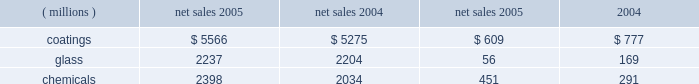Management 2019s discussion and analysis action antitrust legal settlement .
Net income for 2005 and 2004 included an aftertax charge of $ 13 million , or 8 cents a share , and $ 19 million , or 11 cents a share , respectively , to reflect the net increase in the current value of the company 2019s obligation under the ppg settlement arrangement relating to asbestos claims .
Results of business segments net sales operating income ( millions ) 2005 2004 2005 2004 .
Coatings sales increased $ 291 million or 5% ( 5 % ) in 2005 .
Sales increased 3% ( 3 % ) due to higher selling prices across all businesses except automotive ; 1% ( 1 % ) due to improved volumes as increases in our aerospace , architectural and original equipment automotive businesses offset volume declines in automotive refinish and industrial coatings ; and 1% ( 1 % ) due to the positive effects of foreign currency translation .
Operating income decreased $ 168 million in 2005 .
The adverse impact of inflation totaled $ 315 million , of which $ 245 million was attributable to higher raw material costs .
Higher year-over-year selling prices increased operating earnings by $ 169 million .
Coatings operating earnings were reduced by the $ 132 million charge for the cost of the marvin legal settlement net of insurance recoveries .
Other factors increasing coatings operating income in 2005 were the increased sales volumes described above , manufacturing efficiencies , formula cost reductions and higher other income .
Glass sales increased $ 33 million or 1% ( 1 % ) in 2005 .
Sales increased 1% ( 1 % ) due to improved volumes as increases in our automotive replacement glass , insurance and services and performance glazings ( flat glass ) businesses offset volume declines in our fiber glass and automotive original equipment glass businesses .
The positive effects of foreign currency translation were largely offset by lower selling prices primarily in our automotive replacement glass and automotive original equipment businesses .
Operating income decreased $ 113 million in 2005 .
The federal glass class action antitrust legal settlement of $ 61 million , the $ 49 million impact of rising natural gas costs and the absence of the $ 19 million gain in 2004 from the sale/ leaseback of precious metal combined to account for a reduction in operating earnings of $ 129 million .
The remaining year-over-year increase in glass operating earnings of $ 16 million resulted primarily from improved manufacturing efficiencies and lower overhead costs exceeding the adverse impact of other inflation .
Our continuing efforts in 2005 to position the fiber glass business for future growth in profitability were adversely impacted by the rise in fourth quarter natural gas prices , slightly lower year-over-year sales , lower equity earnings due to weaker pricing in the asian electronics market , and the absence of the $ 19 million gain which occurred in 2004 stemming from the sale/ leaseback of precious metals .
Despite high energy costs , we expect fiber glass earnings to improve in 2006 because of price strengthening in the asian electronics market , which began to occur in the fourth quarter of 2005 , increased cost reduction initiatives and the positive impact resulting from the start up of our new joint venture in china .
This joint venture will produce high labor content fiber glass reinforcement products and take advantage of lower labor costs , allowing us to refocus our u.s .
Production capacity on higher margin direct process products .
The 2005 operating earnings of our north american automotive oem glass business declined by $ 30 million compared with 2004 .
Significant structural changes continue to occur in the north american automotive industry , including the loss of u.s .
Market share by general motors and ford .
This has created a very challenging and competitive environment for all suppliers to the domestic oems , including our business .
About half of the decline in earnings resulted from the impact of rising natural gas costs , particularly in the fourth quarter , combined with the traditional adverse impact of year-over-year sales price reductions producing a decline in earnings that exceeded our successful efforts to reduce manufacturing costs .
The other half of the 2005 decline was due to lower sales volumes and mix and higher new program launch costs .
The challenging competitive environment and high energy prices will continue in 2006 .
Our business is working in 2006 to improve its performance through increased manufacturing efficiencies , structural cost reduction initiatives , focusing on profitable growth opportunities and improving our sales mix .
Chemicals sales increased $ 364 million or 18% ( 18 % ) in 2005 .
Sales increased 21% ( 21 % ) due to higher selling prices , primarily for chlor-alkali products , and 1% ( 1 % ) due to the combination of an acquisition in our optical products business and the positive effects of foreign currency translation .
Total volumes declined 4% ( 4 % ) as volume increases in optical products were more than offset by volume declines in chlor-alkali and fine chemicals .
Volume in chlor-alkali products and silicas were adversely impacted in the third and fourth quarters by the hurricanes .
Operating income increased $ 160 million in 2005 .
The primary factor increasing operating income was the record high selling prices in chlor-alkali .
Factors decreasing operating income were higher inflation , including $ 136 million due to increased energy and ethylene costs ; $ 34 million of direct costs related to the impact of the hurricanes ; $ 27 million due to the asset impairment charge related to our fine chemicals business ; lower sales volumes ; higher manufacturing costs and increased environmental expenses .
The increase in chemicals operating earnings occurred primarily through the first eight months of 2005 .
The hurricanes hit in september impacting volumes and costs in september through november and contributing to the rise in natural gas prices which lowered fourth quarter chemicals earnings by $ 58 million , almost 57% ( 57 % ) of the full year impact of higher natural gas prices .
The damage caused by hurricane rita resulted in the shutdown of our lake charles , la chemical plant for a total of eight days in september and an additional five 18 2005 ppg annual report and form 10-k .
What was the operating margin for the coatings segment in 2004? 
Computations: (777 / 5275)
Answer: 0.1473. 